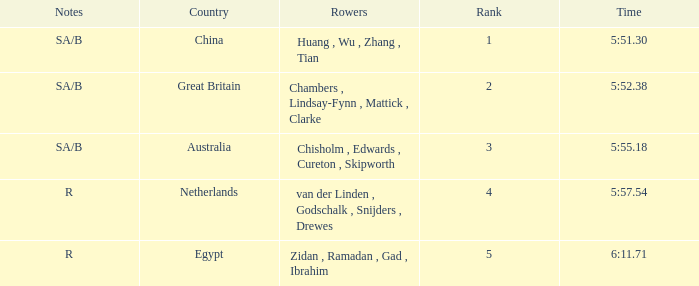What country has sa/b as the notes, and a time of 5:51.30? China. Parse the table in full. {'header': ['Notes', 'Country', 'Rowers', 'Rank', 'Time'], 'rows': [['SA/B', 'China', 'Huang , Wu , Zhang , Tian', '1', '5:51.30'], ['SA/B', 'Great Britain', 'Chambers , Lindsay-Fynn , Mattick , Clarke', '2', '5:52.38'], ['SA/B', 'Australia', 'Chisholm , Edwards , Cureton , Skipworth', '3', '5:55.18'], ['R', 'Netherlands', 'van der Linden , Godschalk , Snijders , Drewes', '4', '5:57.54'], ['R', 'Egypt', 'Zidan , Ramadan , Gad , Ibrahim', '5', '6:11.71']]} 